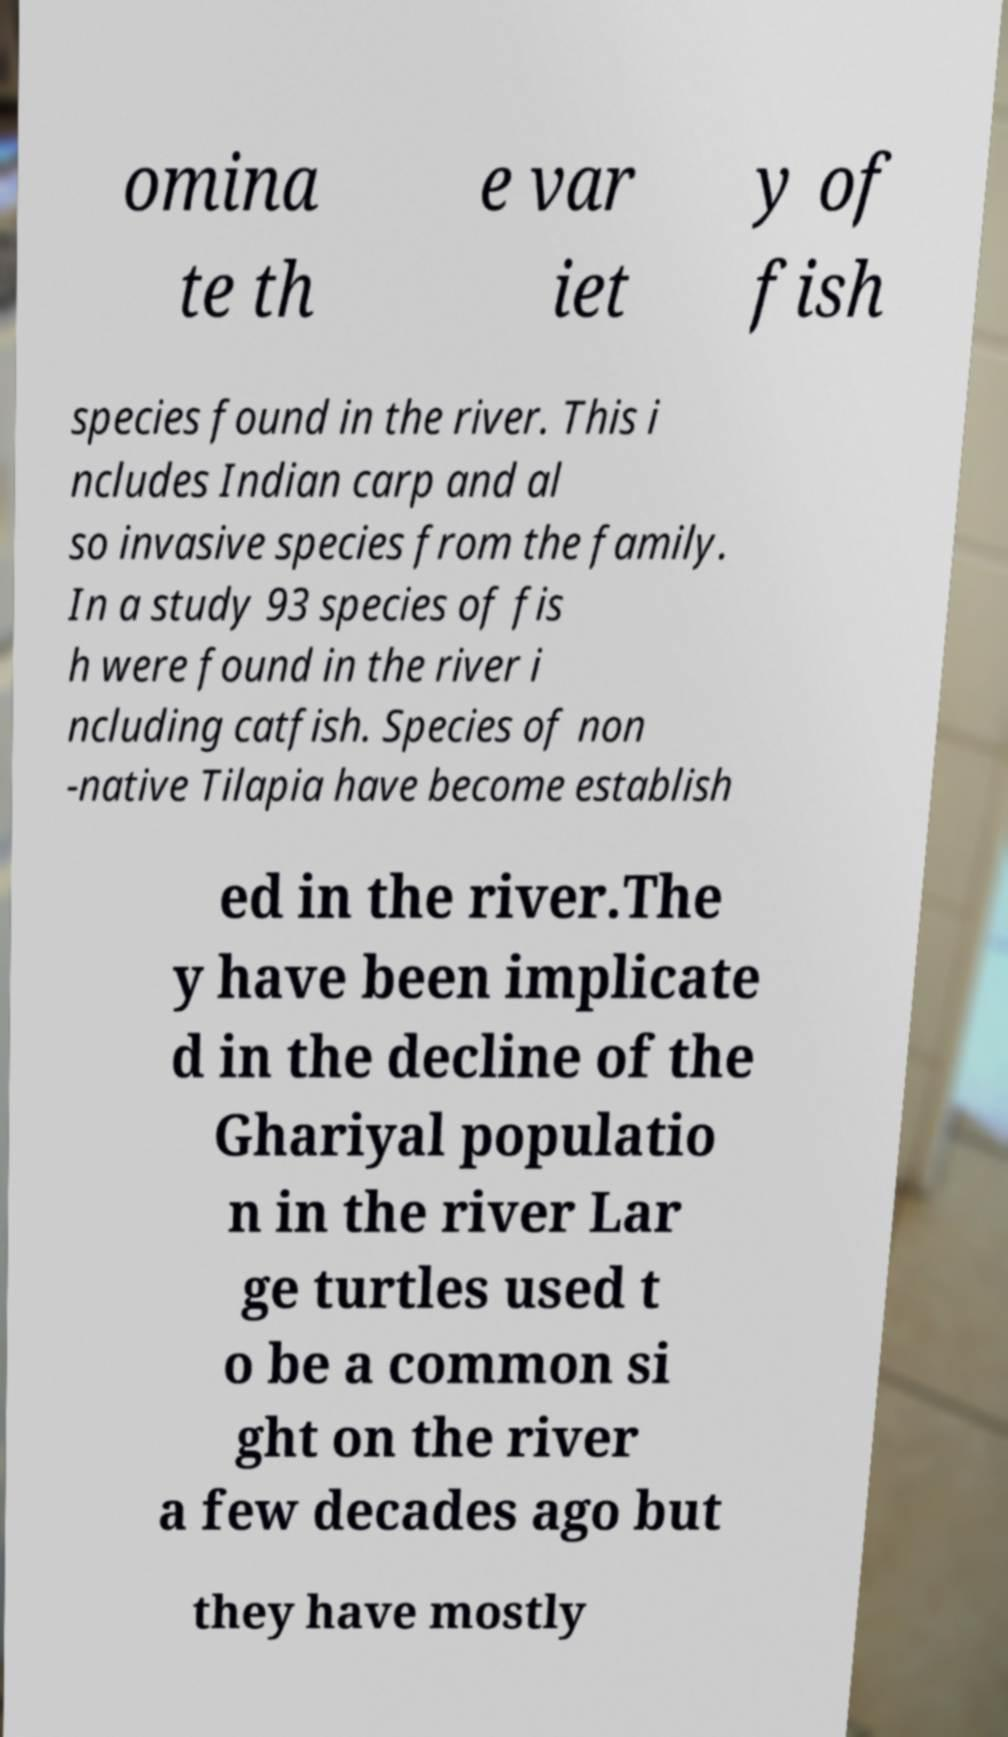Could you extract and type out the text from this image? omina te th e var iet y of fish species found in the river. This i ncludes Indian carp and al so invasive species from the family. In a study 93 species of fis h were found in the river i ncluding catfish. Species of non -native Tilapia have become establish ed in the river.The y have been implicate d in the decline of the Ghariyal populatio n in the river Lar ge turtles used t o be a common si ght on the river a few decades ago but they have mostly 